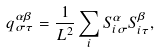<formula> <loc_0><loc_0><loc_500><loc_500>q _ { \sigma \tau } ^ { \alpha \beta } = \frac { 1 } { L ^ { 2 } } \sum _ { i } S _ { i \sigma } ^ { \alpha } S _ { i \tau } ^ { \beta } ,</formula> 